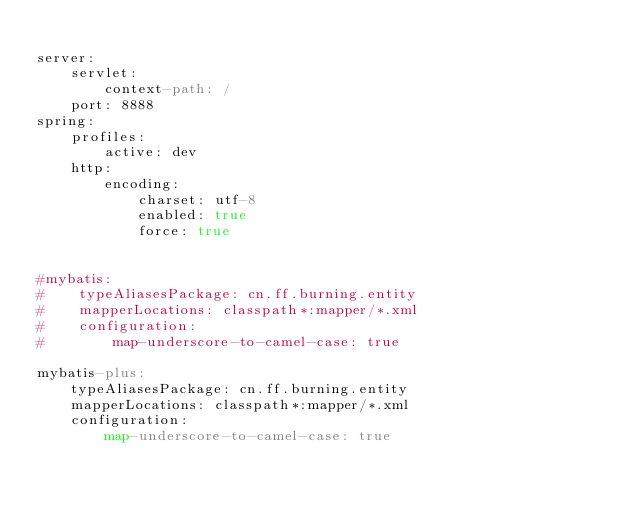<code> <loc_0><loc_0><loc_500><loc_500><_YAML_>
server:
    servlet:
        context-path: /
    port: 8888
spring:
    profiles:
        active: dev
    http:
        encoding:
            charset: utf-8
            enabled: true
            force: true


#mybatis:
#    typeAliasesPackage: cn.ff.burning.entity
#    mapperLocations: classpath*:mapper/*.xml
#    configuration:
#        map-underscore-to-camel-case: true

mybatis-plus:
    typeAliasesPackage: cn.ff.burning.entity
    mapperLocations: classpath*:mapper/*.xml
    configuration:
        map-underscore-to-camel-case: true
</code> 